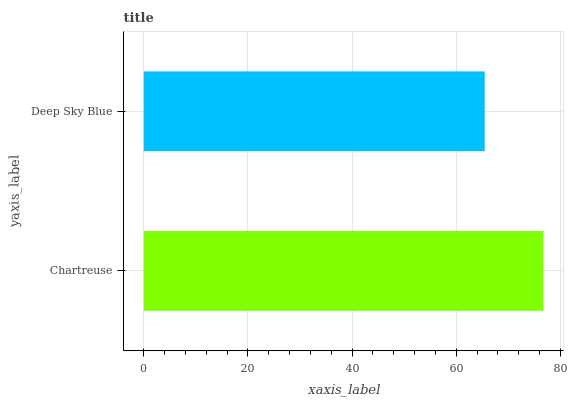Is Deep Sky Blue the minimum?
Answer yes or no. Yes. Is Chartreuse the maximum?
Answer yes or no. Yes. Is Deep Sky Blue the maximum?
Answer yes or no. No. Is Chartreuse greater than Deep Sky Blue?
Answer yes or no. Yes. Is Deep Sky Blue less than Chartreuse?
Answer yes or no. Yes. Is Deep Sky Blue greater than Chartreuse?
Answer yes or no. No. Is Chartreuse less than Deep Sky Blue?
Answer yes or no. No. Is Chartreuse the high median?
Answer yes or no. Yes. Is Deep Sky Blue the low median?
Answer yes or no. Yes. Is Deep Sky Blue the high median?
Answer yes or no. No. Is Chartreuse the low median?
Answer yes or no. No. 